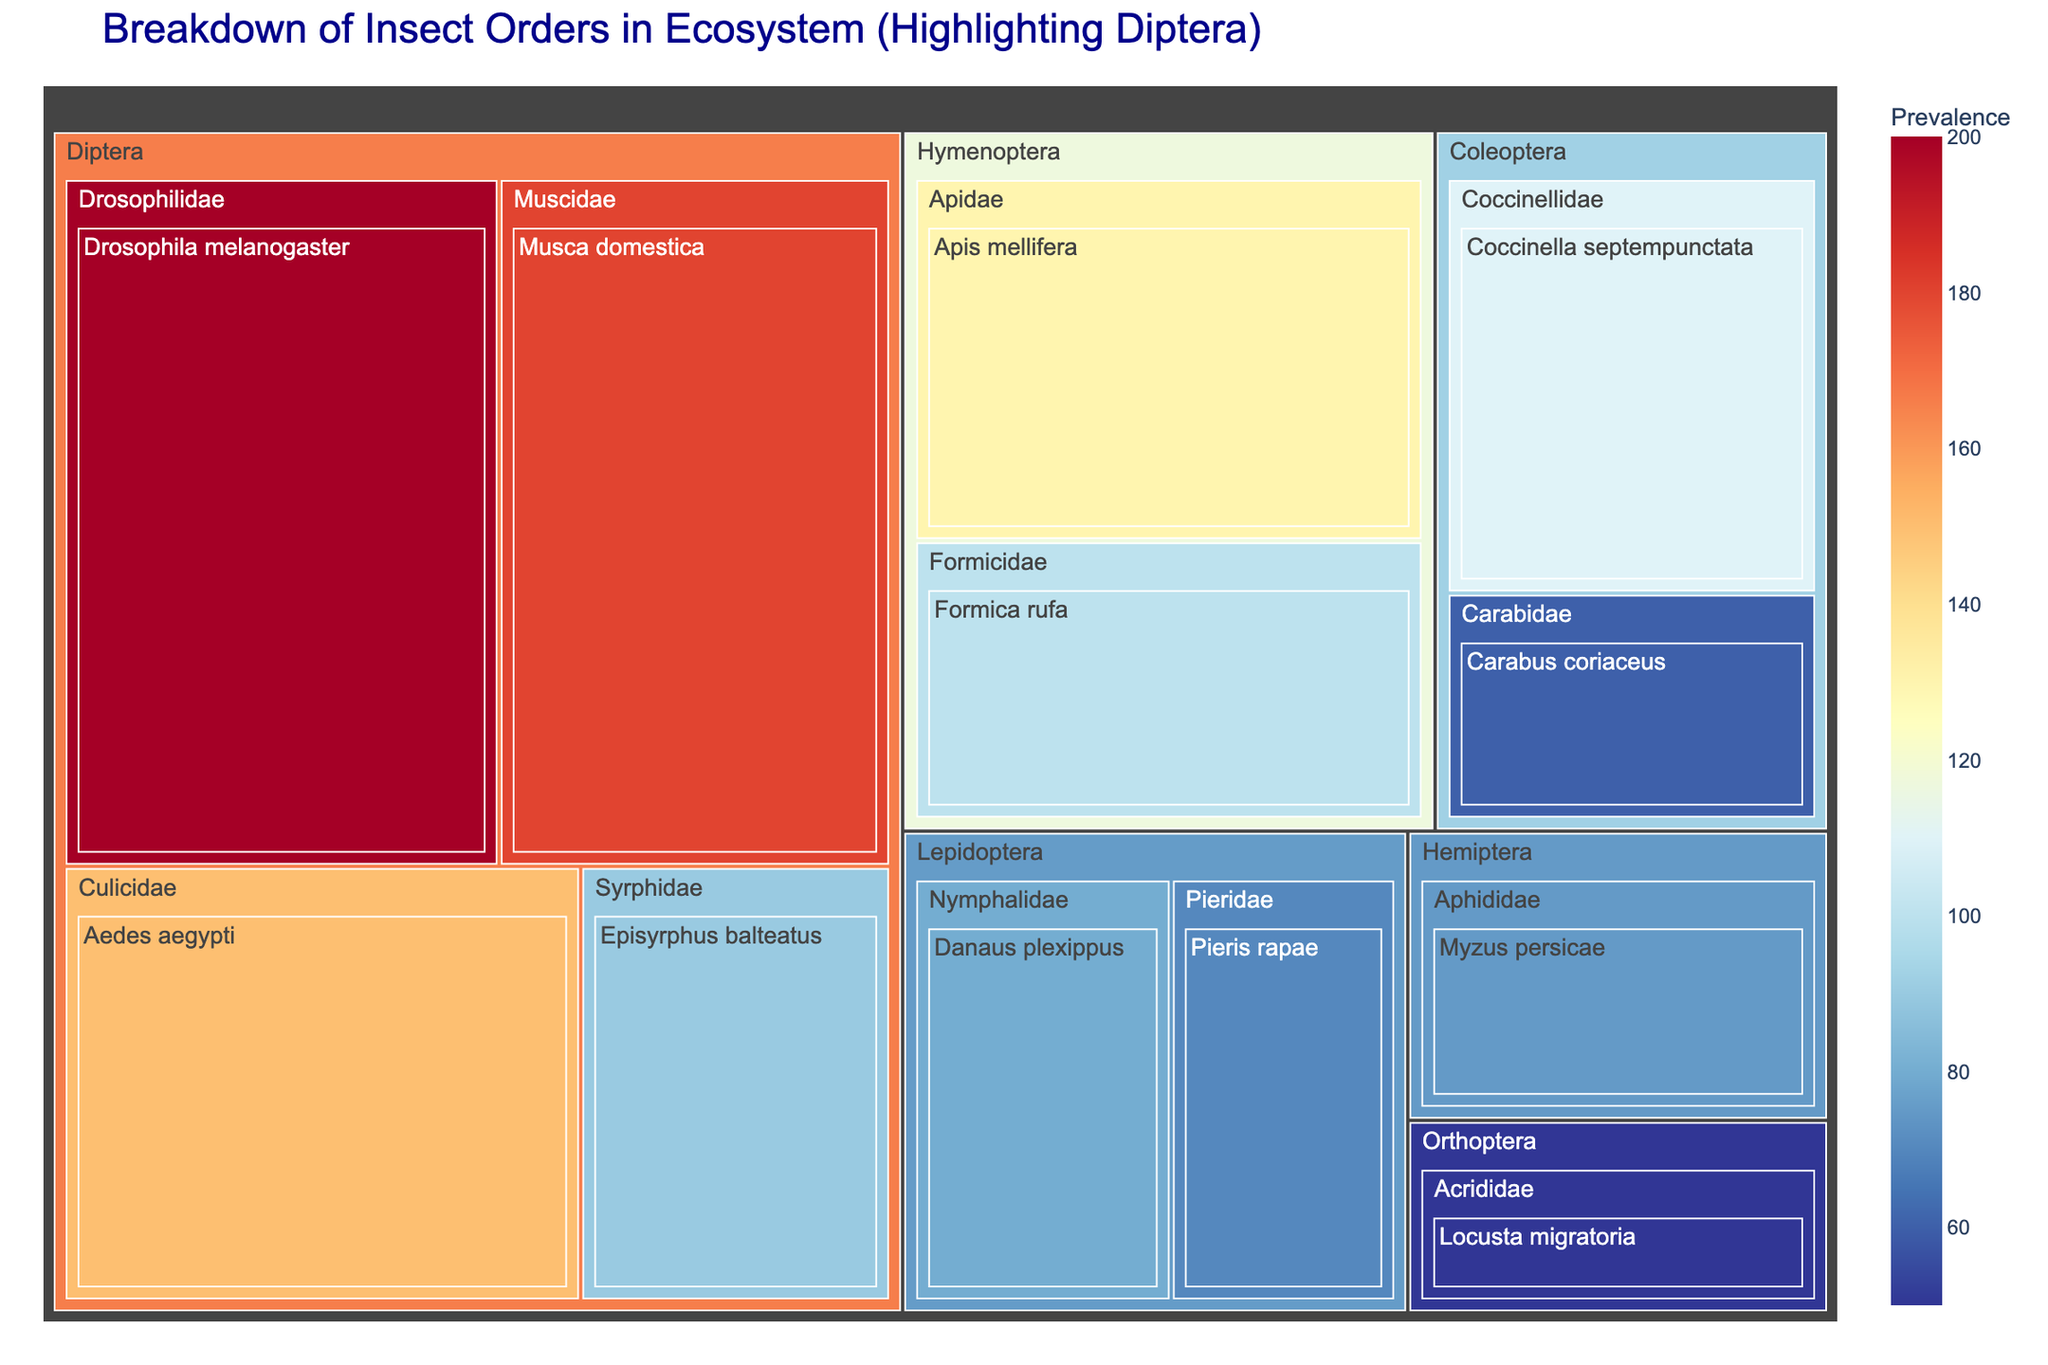what is the title of the figure? The title is displayed prominently at the top of the figure, providing the main descriptive text of the visualization.
Answer: Breakdown of Insect Orders in Ecosystem (Highlighting Diptera) Which species under Diptera has the highest prevalence? Find the Diptera section and compare the prevalence values of species listed under it.
Answer: Drosophila melanogaster How many species from the order Lepidoptera are represented in the treemap? Locate the Lepidoptera section in the treemap and count the number of distinct species displayed.
Answer: 2 What is the total prevalence of all Orthoptera and Hemiptera species combined? Locate the Orthoptera and Hemiptera sections and sum their prevalence values: Orthoptera (Locusta migratoria = 50) and Hemiptera (Myzus persicae = 75). Total = 50 + 75.
Answer: 125 Which family within Diptera has the second highest prevalence and what is that value? Locate the Diptera section, compare the prevalence values of families, and determine the second highest value.
Answer: Muscidae, 180 Which insect order other than Diptera has the highest total prevalence? Sum the prevalence values for each order other than Diptera and determine the highest: Lepidoptera (80+70=150), Coleoptera (110+60=170), Hymenoptera (130+100=230), Orthoptera (50), Hemiptera (75). Hymenoptera has the highest.
Answer: Hymenoptera Compare the prevalence of Apidae and Formicidae families within Hymenoptera. Which one is greater and by how much? Locate the Apidae and Formicidae families under Hymenoptera and subtract their prevalence values: Apidae (130) - Formicidae (100).
Answer: Apidae by 30 What is the average prevalence of species within Diptera? Sum the prevalence values within Diptera and divide by the number of species: (150+200+180+90)/4 = 620/4.
Answer: 155 Which orders have a total prevalence greater than 120? Sum the species prevalence within each order and compare with 120. Diptera (620), Lepidoptera (150), Coleoptera (170), Hymenoptera (230), Orthoptera (50), Hemiptera (75). Orders: Diptera, Lepidoptera, Coleoptera, Hymenoptera.
Answer: Diptera, Lepidoptera, Coleoptera, Hymenoptera What is the prevalence difference between the most prevalent and least prevalent species in the whole dataset? Identify the species with the highest and lowest prevalence values and subtract: Highest (Drosophila melanogaster, 200) - Lowest (Locusta migratoria, 50).
Answer: 150 